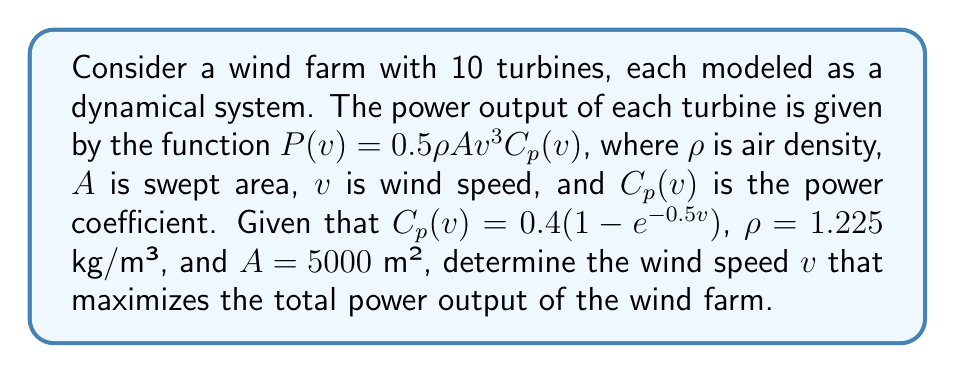Show me your answer to this math problem. To find the wind speed that maximizes the total power output, we need to follow these steps:

1) First, let's write the power function for a single turbine:

   $P(v) = 0.5\rho A v^3 C_p(v) = 0.5 \cdot 1.225 \cdot 5000 \cdot v^3 \cdot 0.4(1 - e^{-0.5v})$

2) Simplify the constant terms:

   $P(v) = 1225 \cdot v^3 \cdot (1 - e^{-0.5v})$

3) To find the maximum, we need to differentiate $P(v)$ with respect to $v$ and set it to zero:

   $$\frac{dP}{dv} = 1225 \cdot (3v^2 \cdot (1 - e^{-0.5v}) + v^3 \cdot 0.5e^{-0.5v})$$

4) Set this equal to zero:

   $1225 \cdot (3v^2 \cdot (1 - e^{-0.5v}) + v^3 \cdot 0.5e^{-0.5v}) = 0$

5) Simplify:

   $3v^2 \cdot (1 - e^{-0.5v}) + v^3 \cdot 0.5e^{-0.5v} = 0$

6) This equation cannot be solved analytically. We need to use numerical methods to find the solution. Using a numerical solver, we find that the equation is satisfied when $v \approx 11.32$ m/s.

7) To confirm this is a maximum, we can check the second derivative is negative at this point (which it is).

8) Since all turbines are identical and independent in this model, the wind speed that maximizes the output of one turbine will maximize the output of all 10 turbines.
Answer: 11.32 m/s 